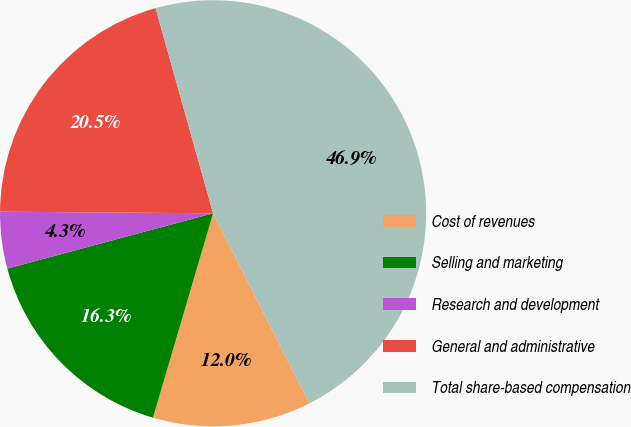<chart> <loc_0><loc_0><loc_500><loc_500><pie_chart><fcel>Cost of revenues<fcel>Selling and marketing<fcel>Research and development<fcel>General and administrative<fcel>Total share-based compensation<nl><fcel>12.01%<fcel>16.27%<fcel>4.3%<fcel>20.53%<fcel>46.9%<nl></chart> 